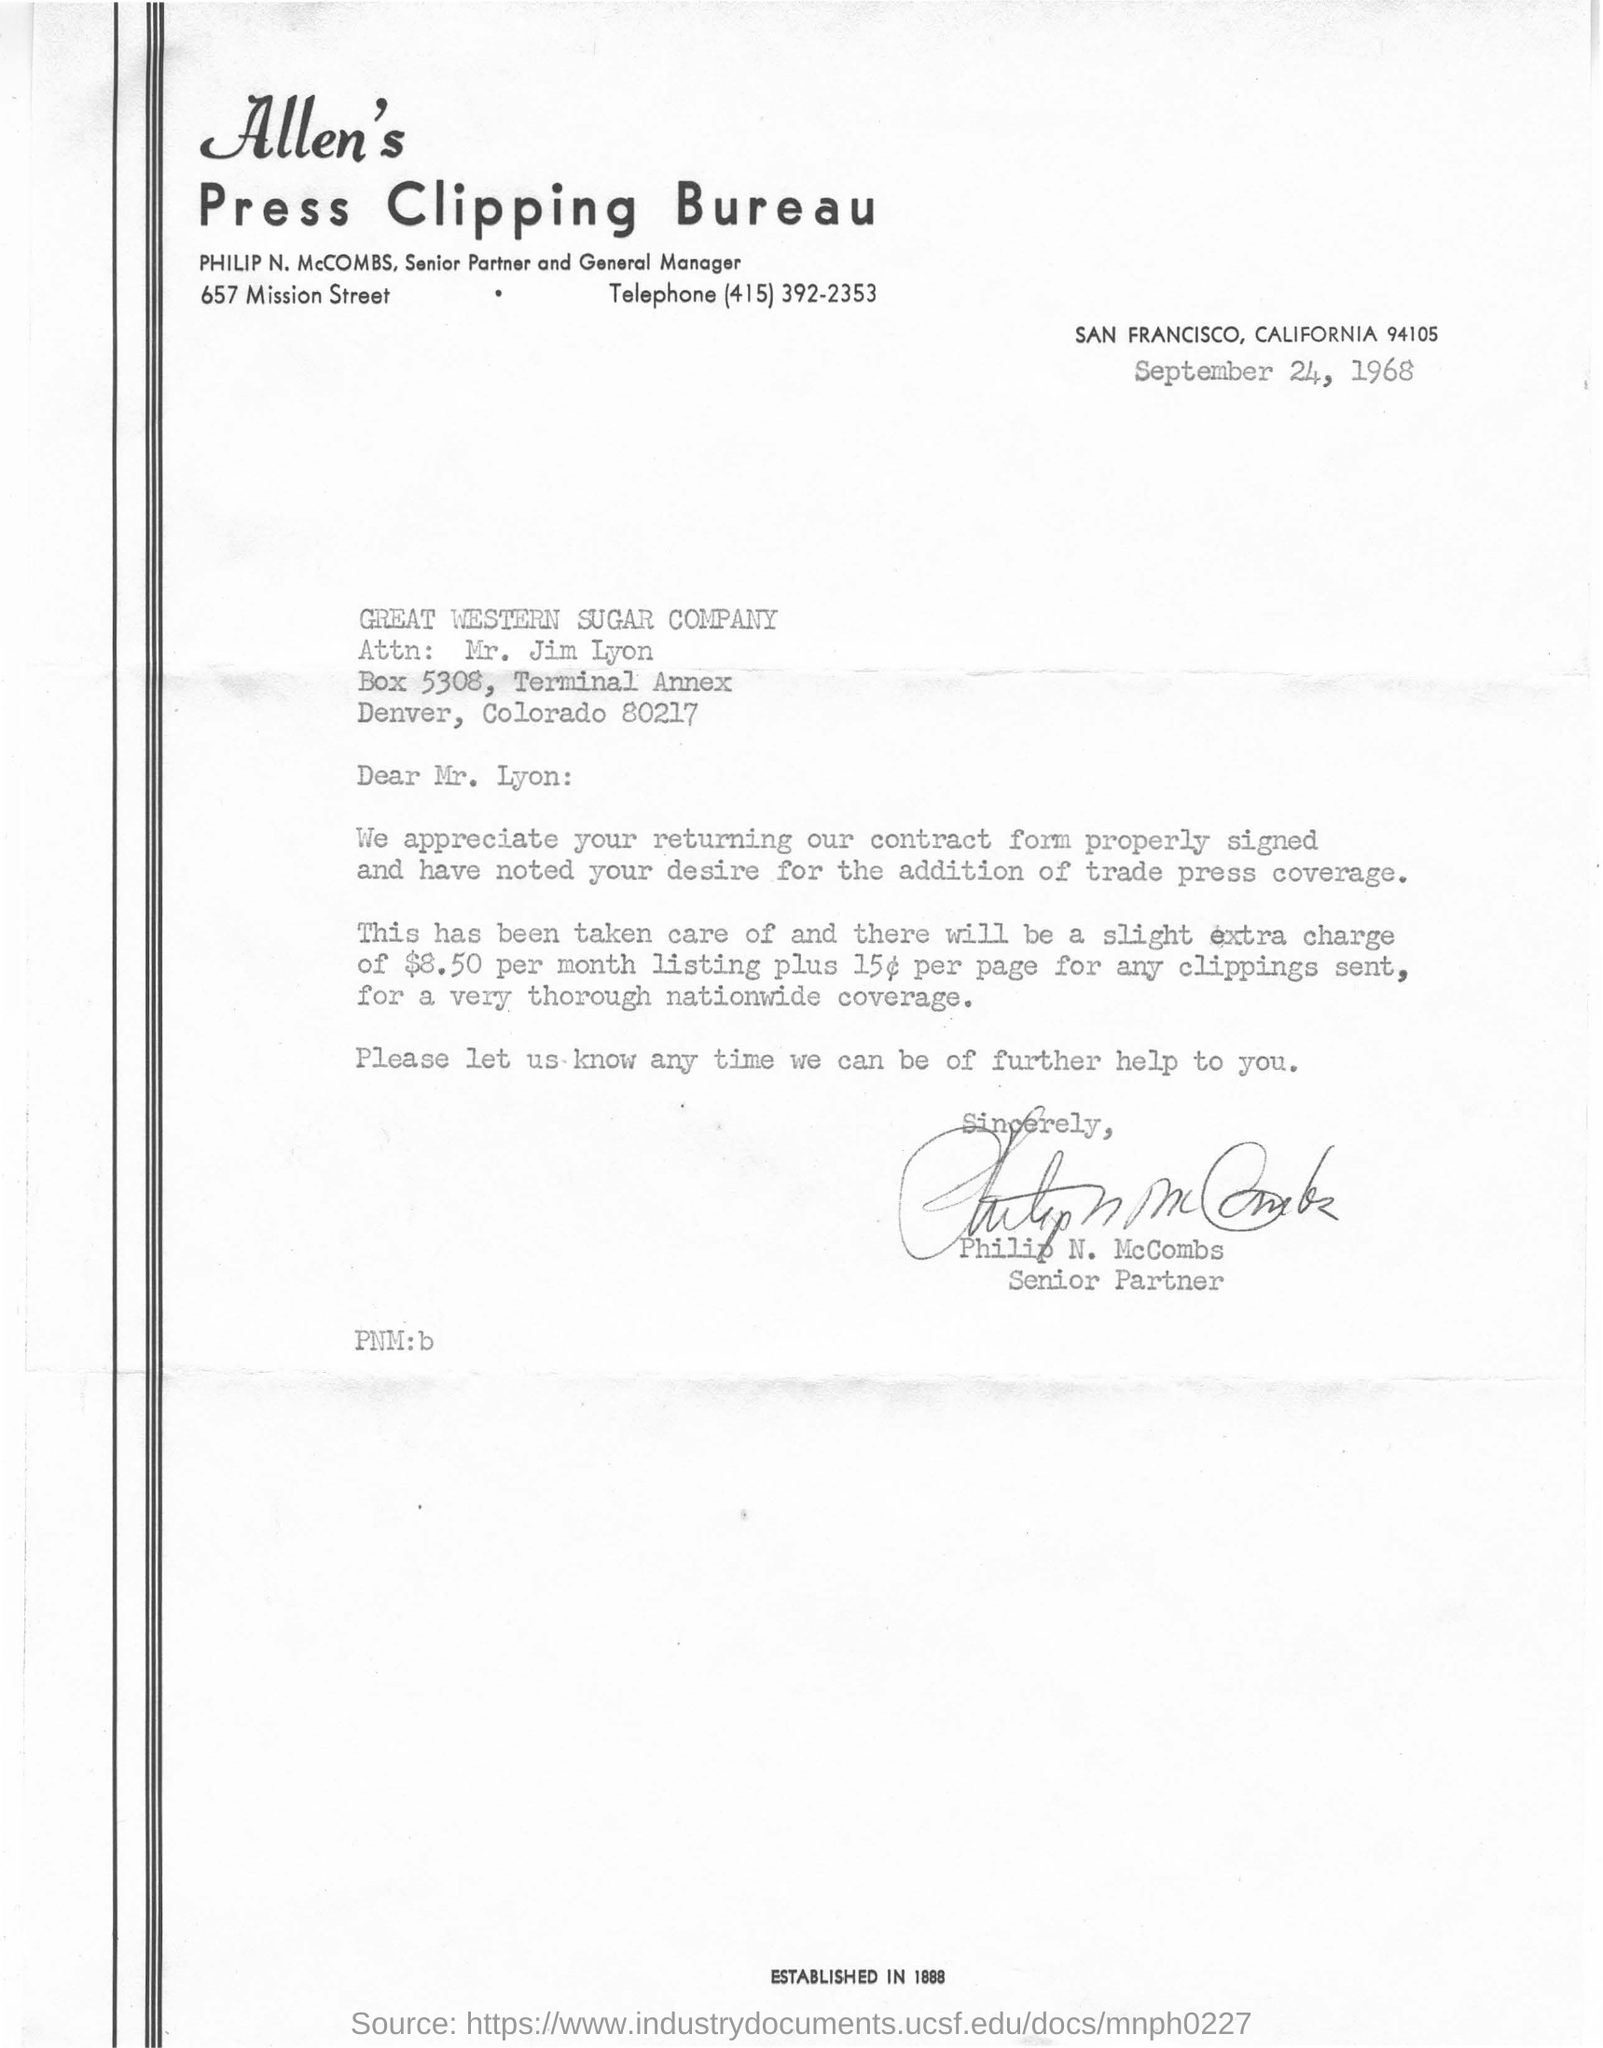Outline some significant characteristics in this image. The document indicates that the date mentioned is September 24, 1968. Philip N. McCombs is a senior partner. 